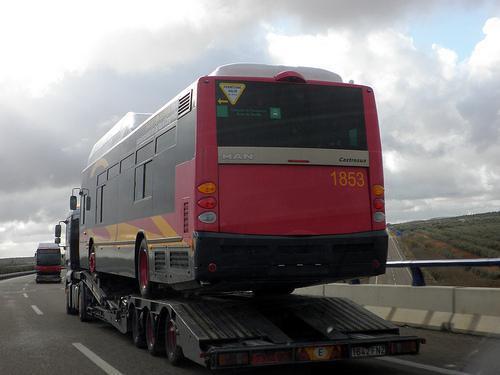How many trucks are driving on the highway?
Give a very brief answer. 2. 